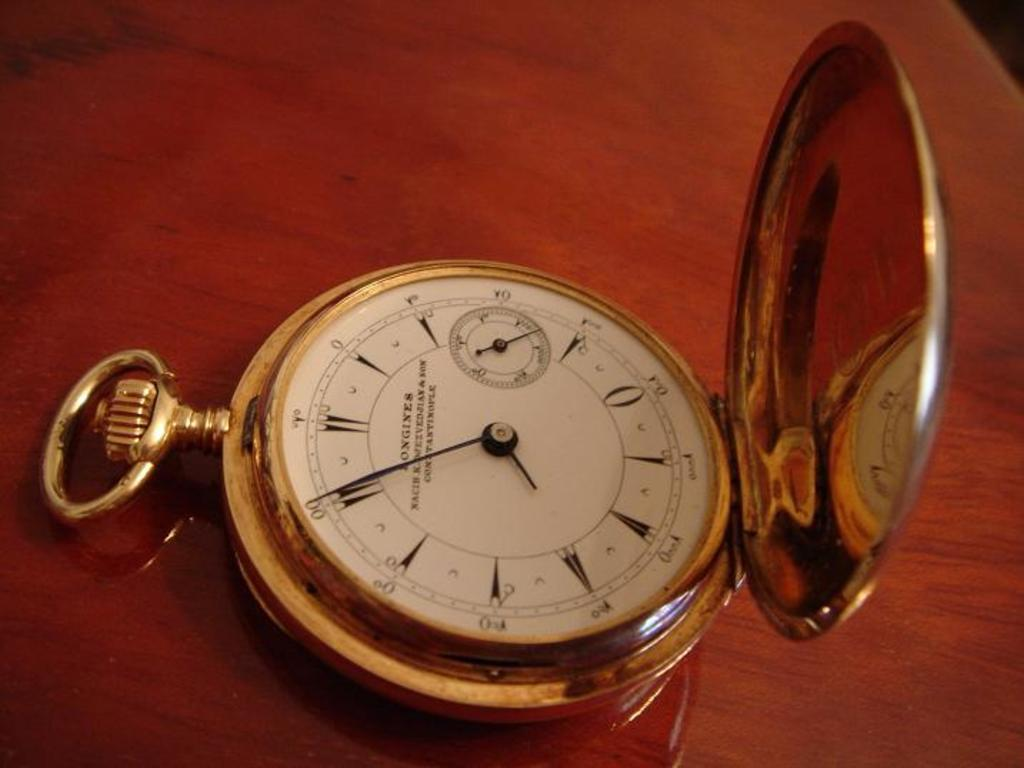Provide a one-sentence caption for the provided image. A Longines pocket watch has a gold case. 